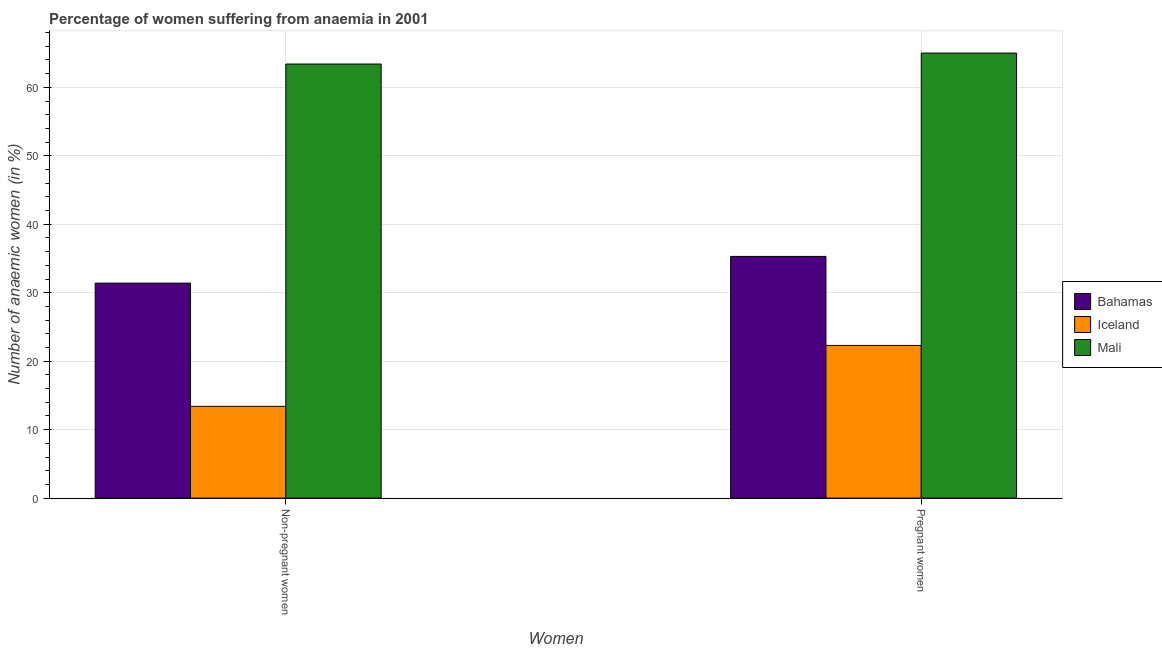How many different coloured bars are there?
Offer a terse response. 3. Are the number of bars per tick equal to the number of legend labels?
Provide a short and direct response. Yes. How many bars are there on the 1st tick from the right?
Your answer should be compact. 3. What is the label of the 1st group of bars from the left?
Offer a terse response. Non-pregnant women. What is the percentage of pregnant anaemic women in Iceland?
Offer a very short reply. 22.3. Across all countries, what is the maximum percentage of non-pregnant anaemic women?
Offer a very short reply. 63.4. Across all countries, what is the minimum percentage of pregnant anaemic women?
Keep it short and to the point. 22.3. In which country was the percentage of non-pregnant anaemic women maximum?
Keep it short and to the point. Mali. In which country was the percentage of pregnant anaemic women minimum?
Ensure brevity in your answer.  Iceland. What is the total percentage of pregnant anaemic women in the graph?
Offer a very short reply. 122.6. What is the difference between the percentage of non-pregnant anaemic women in Iceland and that in Mali?
Give a very brief answer. -50. What is the difference between the percentage of pregnant anaemic women in Mali and the percentage of non-pregnant anaemic women in Bahamas?
Ensure brevity in your answer.  33.6. What is the average percentage of pregnant anaemic women per country?
Provide a succinct answer. 40.87. What is the ratio of the percentage of pregnant anaemic women in Iceland to that in Bahamas?
Your answer should be very brief. 0.63. Is the percentage of pregnant anaemic women in Iceland less than that in Bahamas?
Ensure brevity in your answer.  Yes. In how many countries, is the percentage of non-pregnant anaemic women greater than the average percentage of non-pregnant anaemic women taken over all countries?
Ensure brevity in your answer.  1. What does the 3rd bar from the right in Non-pregnant women represents?
Ensure brevity in your answer.  Bahamas. How many bars are there?
Provide a succinct answer. 6. What is the difference between two consecutive major ticks on the Y-axis?
Offer a very short reply. 10. Does the graph contain any zero values?
Keep it short and to the point. No. Where does the legend appear in the graph?
Your response must be concise. Center right. How are the legend labels stacked?
Your answer should be very brief. Vertical. What is the title of the graph?
Keep it short and to the point. Percentage of women suffering from anaemia in 2001. Does "St. Martin (French part)" appear as one of the legend labels in the graph?
Your response must be concise. No. What is the label or title of the X-axis?
Provide a short and direct response. Women. What is the label or title of the Y-axis?
Provide a succinct answer. Number of anaemic women (in %). What is the Number of anaemic women (in %) in Bahamas in Non-pregnant women?
Provide a short and direct response. 31.4. What is the Number of anaemic women (in %) of Mali in Non-pregnant women?
Provide a succinct answer. 63.4. What is the Number of anaemic women (in %) in Bahamas in Pregnant women?
Make the answer very short. 35.3. What is the Number of anaemic women (in %) in Iceland in Pregnant women?
Make the answer very short. 22.3. Across all Women, what is the maximum Number of anaemic women (in %) of Bahamas?
Offer a terse response. 35.3. Across all Women, what is the maximum Number of anaemic women (in %) of Iceland?
Your response must be concise. 22.3. Across all Women, what is the maximum Number of anaemic women (in %) in Mali?
Make the answer very short. 65. Across all Women, what is the minimum Number of anaemic women (in %) of Bahamas?
Make the answer very short. 31.4. Across all Women, what is the minimum Number of anaemic women (in %) in Mali?
Provide a short and direct response. 63.4. What is the total Number of anaemic women (in %) in Bahamas in the graph?
Offer a terse response. 66.7. What is the total Number of anaemic women (in %) of Iceland in the graph?
Your answer should be very brief. 35.7. What is the total Number of anaemic women (in %) of Mali in the graph?
Keep it short and to the point. 128.4. What is the difference between the Number of anaemic women (in %) in Bahamas in Non-pregnant women and the Number of anaemic women (in %) in Iceland in Pregnant women?
Your response must be concise. 9.1. What is the difference between the Number of anaemic women (in %) in Bahamas in Non-pregnant women and the Number of anaemic women (in %) in Mali in Pregnant women?
Your answer should be compact. -33.6. What is the difference between the Number of anaemic women (in %) in Iceland in Non-pregnant women and the Number of anaemic women (in %) in Mali in Pregnant women?
Make the answer very short. -51.6. What is the average Number of anaemic women (in %) of Bahamas per Women?
Your response must be concise. 33.35. What is the average Number of anaemic women (in %) of Iceland per Women?
Provide a succinct answer. 17.85. What is the average Number of anaemic women (in %) of Mali per Women?
Your answer should be very brief. 64.2. What is the difference between the Number of anaemic women (in %) in Bahamas and Number of anaemic women (in %) in Mali in Non-pregnant women?
Keep it short and to the point. -32. What is the difference between the Number of anaemic women (in %) of Iceland and Number of anaemic women (in %) of Mali in Non-pregnant women?
Give a very brief answer. -50. What is the difference between the Number of anaemic women (in %) of Bahamas and Number of anaemic women (in %) of Mali in Pregnant women?
Your response must be concise. -29.7. What is the difference between the Number of anaemic women (in %) in Iceland and Number of anaemic women (in %) in Mali in Pregnant women?
Provide a short and direct response. -42.7. What is the ratio of the Number of anaemic women (in %) of Bahamas in Non-pregnant women to that in Pregnant women?
Your answer should be compact. 0.89. What is the ratio of the Number of anaemic women (in %) in Iceland in Non-pregnant women to that in Pregnant women?
Give a very brief answer. 0.6. What is the ratio of the Number of anaemic women (in %) in Mali in Non-pregnant women to that in Pregnant women?
Your answer should be very brief. 0.98. What is the difference between the highest and the second highest Number of anaemic women (in %) of Bahamas?
Your answer should be compact. 3.9. What is the difference between the highest and the second highest Number of anaemic women (in %) of Mali?
Your response must be concise. 1.6. What is the difference between the highest and the lowest Number of anaemic women (in %) in Mali?
Provide a succinct answer. 1.6. 